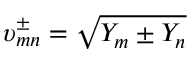<formula> <loc_0><loc_0><loc_500><loc_500>\upsilon _ { m n } ^ { \pm } = \sqrt { Y _ { m } \pm Y _ { n } }</formula> 